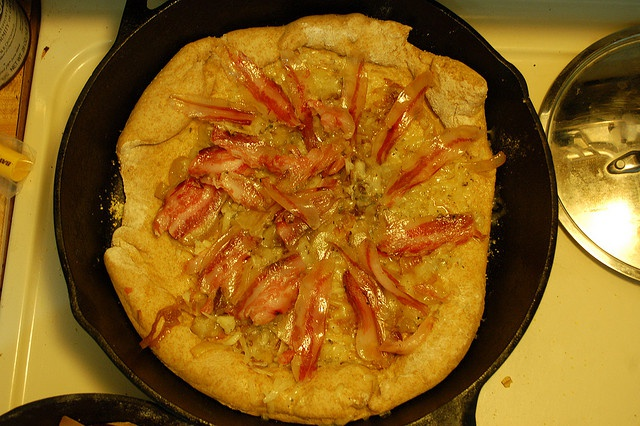Describe the objects in this image and their specific colors. I can see a pizza in olive, red, orange, and maroon tones in this image. 